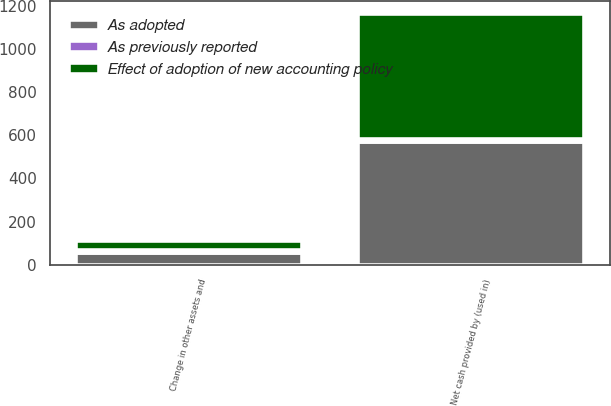<chart> <loc_0><loc_0><loc_500><loc_500><stacked_bar_chart><ecel><fcel>Change in other assets and<fcel>Net cash provided by (used in)<nl><fcel>As adopted<fcel>56.2<fcel>570.9<nl><fcel>As previously reported<fcel>10.6<fcel>10.6<nl><fcel>Effect of adoption of new accounting policy<fcel>45.6<fcel>581.5<nl></chart> 